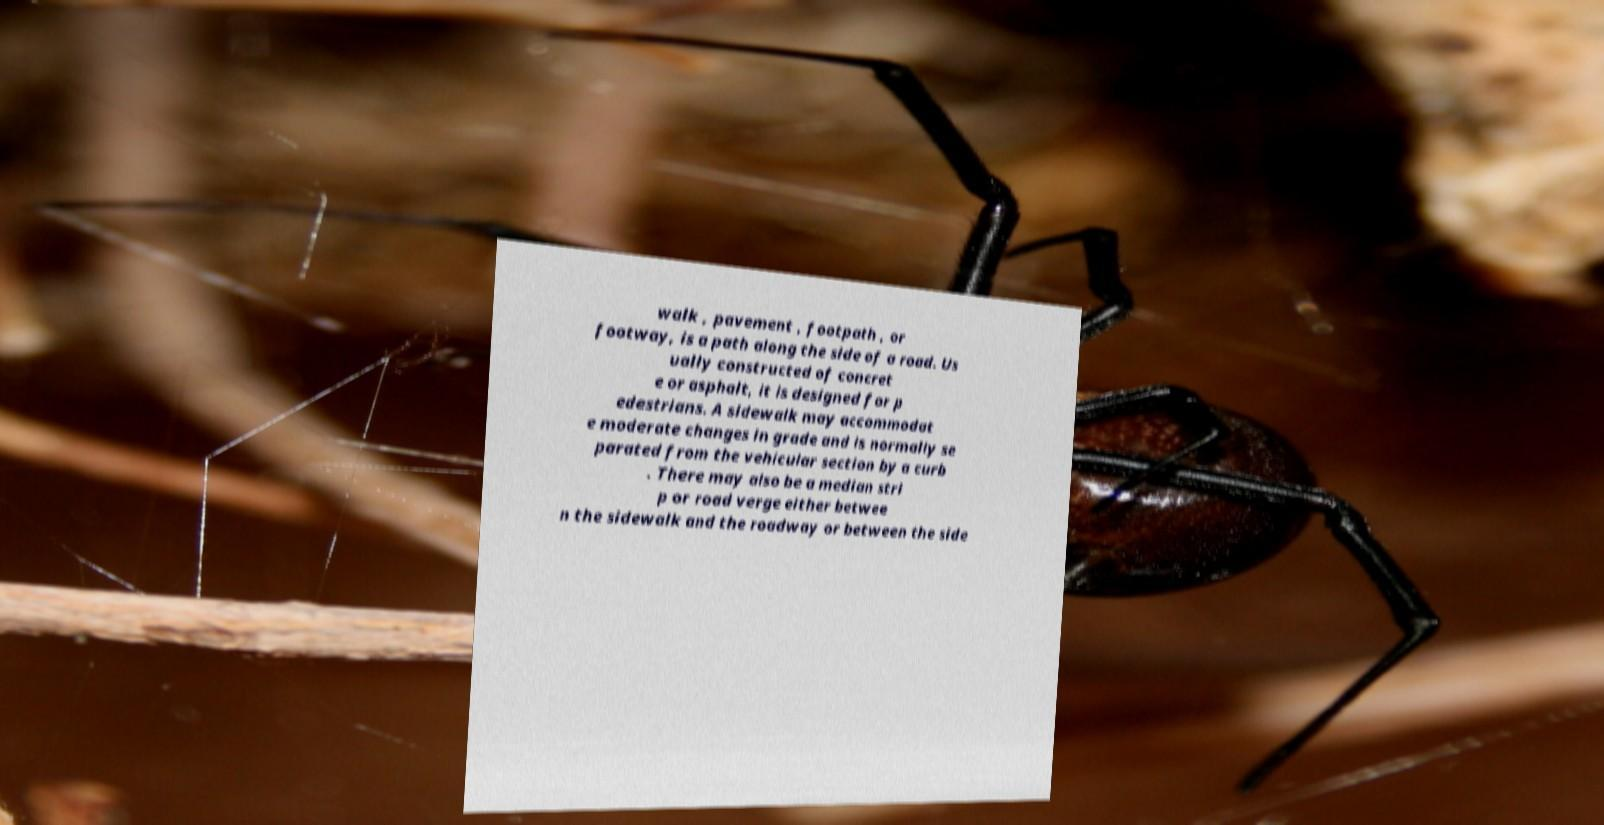Please read and relay the text visible in this image. What does it say? walk , pavement , footpath , or footway, is a path along the side of a road. Us ually constructed of concret e or asphalt, it is designed for p edestrians. A sidewalk may accommodat e moderate changes in grade and is normally se parated from the vehicular section by a curb . There may also be a median stri p or road verge either betwee n the sidewalk and the roadway or between the side 